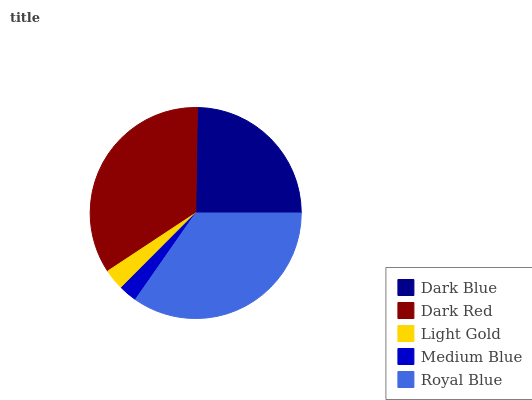Is Medium Blue the minimum?
Answer yes or no. Yes. Is Royal Blue the maximum?
Answer yes or no. Yes. Is Dark Red the minimum?
Answer yes or no. No. Is Dark Red the maximum?
Answer yes or no. No. Is Dark Red greater than Dark Blue?
Answer yes or no. Yes. Is Dark Blue less than Dark Red?
Answer yes or no. Yes. Is Dark Blue greater than Dark Red?
Answer yes or no. No. Is Dark Red less than Dark Blue?
Answer yes or no. No. Is Dark Blue the high median?
Answer yes or no. Yes. Is Dark Blue the low median?
Answer yes or no. Yes. Is Light Gold the high median?
Answer yes or no. No. Is Medium Blue the low median?
Answer yes or no. No. 